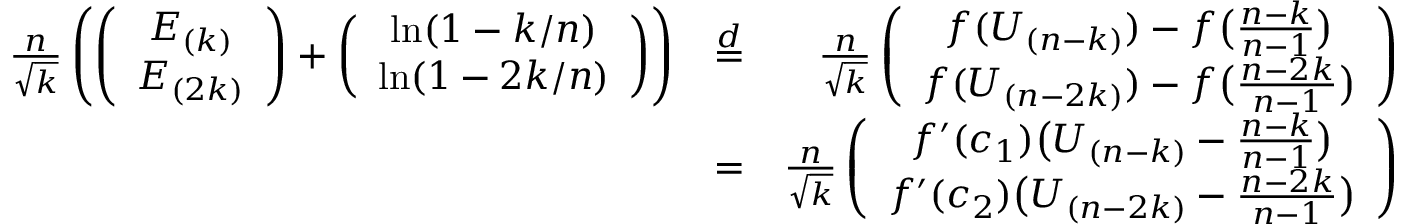Convert formula to latex. <formula><loc_0><loc_0><loc_500><loc_500>\begin{array} { r l r } { \frac { n } { \sqrt { k } } \left ( \left ( \begin{array} { c } { E _ { ( k ) } } \\ { E _ { ( 2 k ) } } \end{array} \right ) + \left ( \begin{array} { c } { \ln ( 1 - k / n ) } \\ { \ln ( 1 - 2 k / n ) } \end{array} \right ) \right ) } & { \stackrel { d } { = } } & { \frac { n } { \sqrt { k } } \left ( \begin{array} { c } { f ( U _ { ( n - k ) } ) - f \left ( \frac { n - k } { n - 1 } \right ) } \\ { f ( U _ { ( n - 2 k ) } ) - f \left ( \frac { n - 2 k } { n - 1 } \right ) } \end{array} \right ) } \\ & { = } & { \frac { n } { \sqrt { k } } \left ( \begin{array} { c } { f ^ { \prime } ( c _ { 1 } ) \left ( U _ { ( n - k ) } - \frac { n - k } { n - 1 } \right ) } \\ { f ^ { \prime } ( c _ { 2 } ) \left ( U _ { ( n - 2 k ) } - \frac { n - 2 k } { n - 1 } \right ) } \end{array} \right ) } \end{array}</formula> 